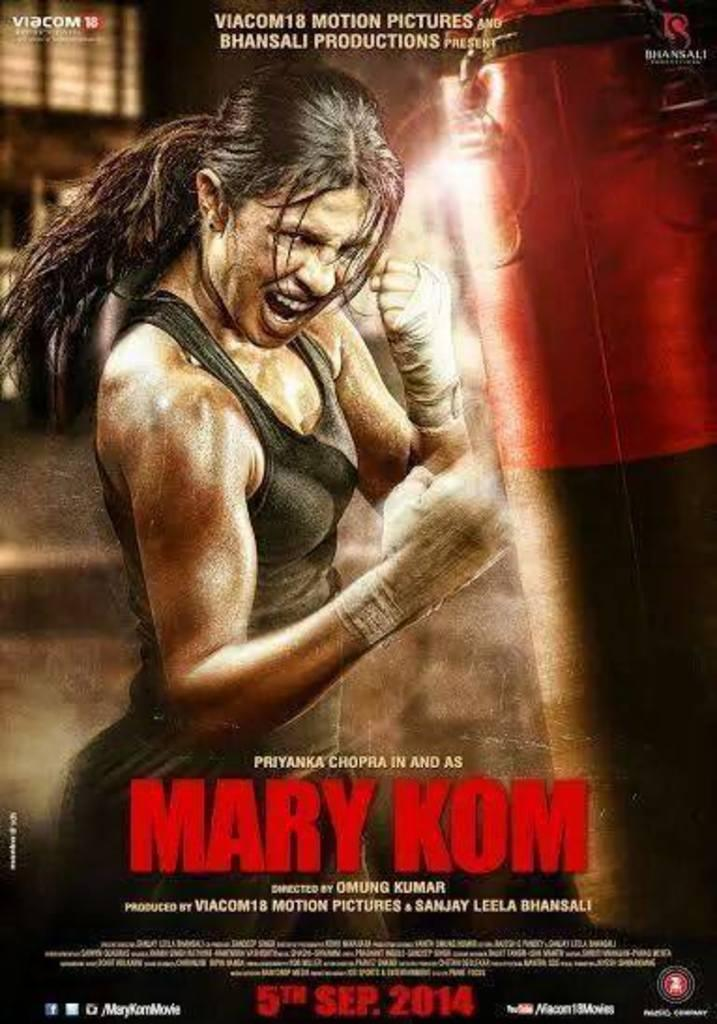<image>
Provide a brief description of the given image. A movie poster advertises the movie Mary Kom. 